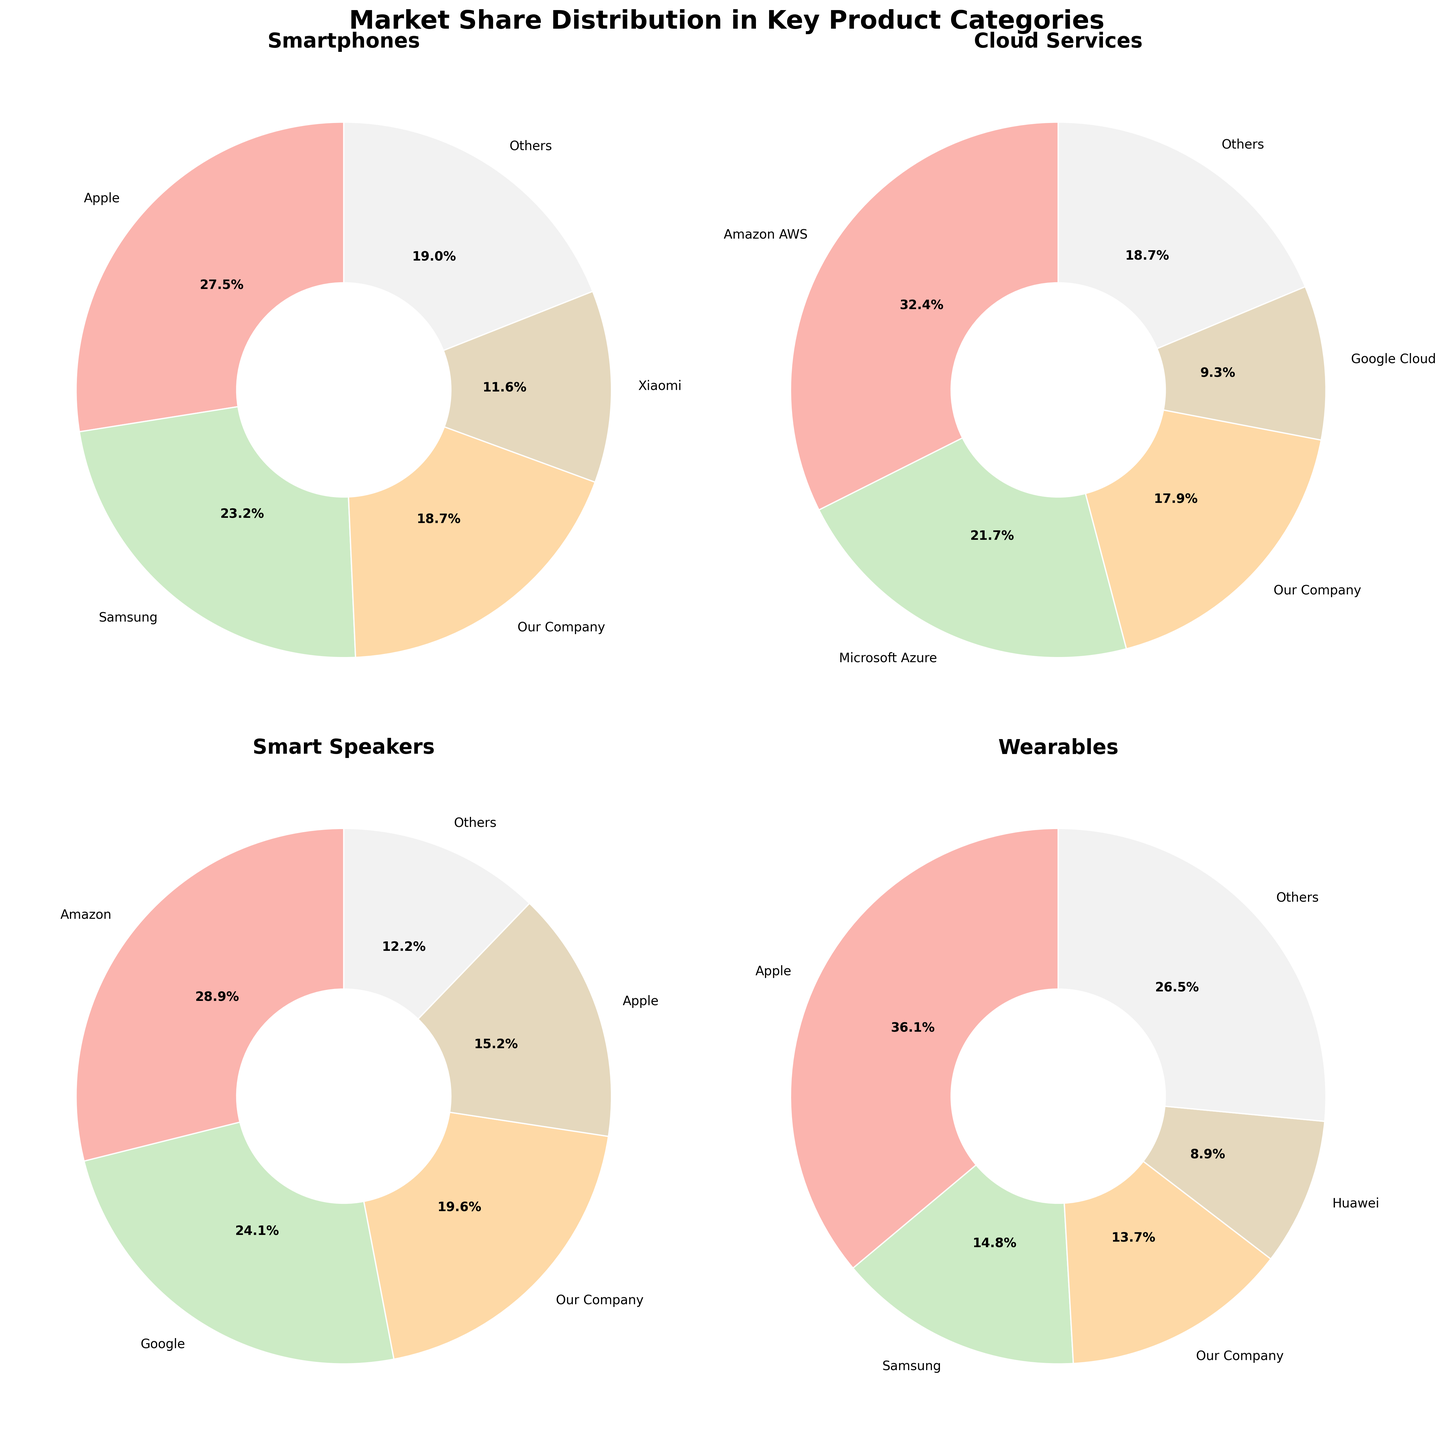Which company has the highest market share in the Wearables category? Look at the Wearables pie chart and identify the company with the largest slice. Apple has the largest slice representing 36.1%.
Answer: Apple What is the difference in market share between Amazon AWS and Microsoft Azure in Cloud Services? In the Cloud Services pie chart, locate both Amazon AWS and Microsoft Azure and note their market shares. Amazon AWS has 32.4% and Microsoft Azure has 21.7%. Subtract 21.7 from 32.4 to find the difference (32.4 - 21.7 = 10.7).
Answer: 10.7% How does Our Company’s market share in Smartphones compare to its market share in Smart Speakers? Identify the slices representing Our Company in both the Smartphones and Smart Speakers pie charts. For Smartphones, Our Company has 18.7%, and for Smart Speakers, it is 19.6%. Compare these two values to see that the market share in Smart Speakers is slightly higher.
Answer: Our Company has a higher market share in Smart Speakers (19.6%) compared to Smartphones (18.7%) What is the total market share of companies other than the leading company in the Smart Speakers category? First, identify the leading company in Smart Speakers, which is Amazon with 28.9%. Then sum up the market shares of the other companies: Google (24.1%), Our Company (19.6%), Apple (15.2%), and Others (12.2%). The sum is calculated as 24.1 + 19.6 + 15.2 + 12.2 = 71.1%.
Answer: 71.1% Comparing Our Company and Samsung, who has a larger share in Wearables and by how much? Identify the market shares of Our Company (13.7%) and Samsung (14.8%) in the Wearables pie chart. Subtract the smaller share from the larger share (14.8% - 13.7% = 1.1%). Samsung has a larger share by 1.1%.
Answer: Samsung by 1.1% Which two companies together hold over half of the smartphone market? Look at the largest slices in the Smartphones pie chart. Apple (27.5%) and Samsung (23.2%) together sum to 50.7%, which is over half. Check adding any other pairs to ensure this is the only combination that sums to over 50%.
Answer: Apple and Samsung What is the average market share of the 'Others' category across all product categories? Identify the market shares of the 'Others' category in each pie chart: Smartphones (19.0%), Cloud Services (18.7%), Smart Speakers (12.2%), and Wearables (26.5%). Sum these shares (19.0 + 18.7 + 12.2 + 26.5 = 76.4) and divide by the number of categories (4), which gives the average as 76.4 / 4 = 19.1%.
Answer: 19.1% Visual questions (Compositional)
Which category has the most evenly distributed market share, indicated by the most similar-sized slices? Assess all four pie charts, observing the slices' sizes. The Cloud Services chart appears to be the most evenly distributed as no single slice dominates as much compared to the others.
Answer: Cloud Services 